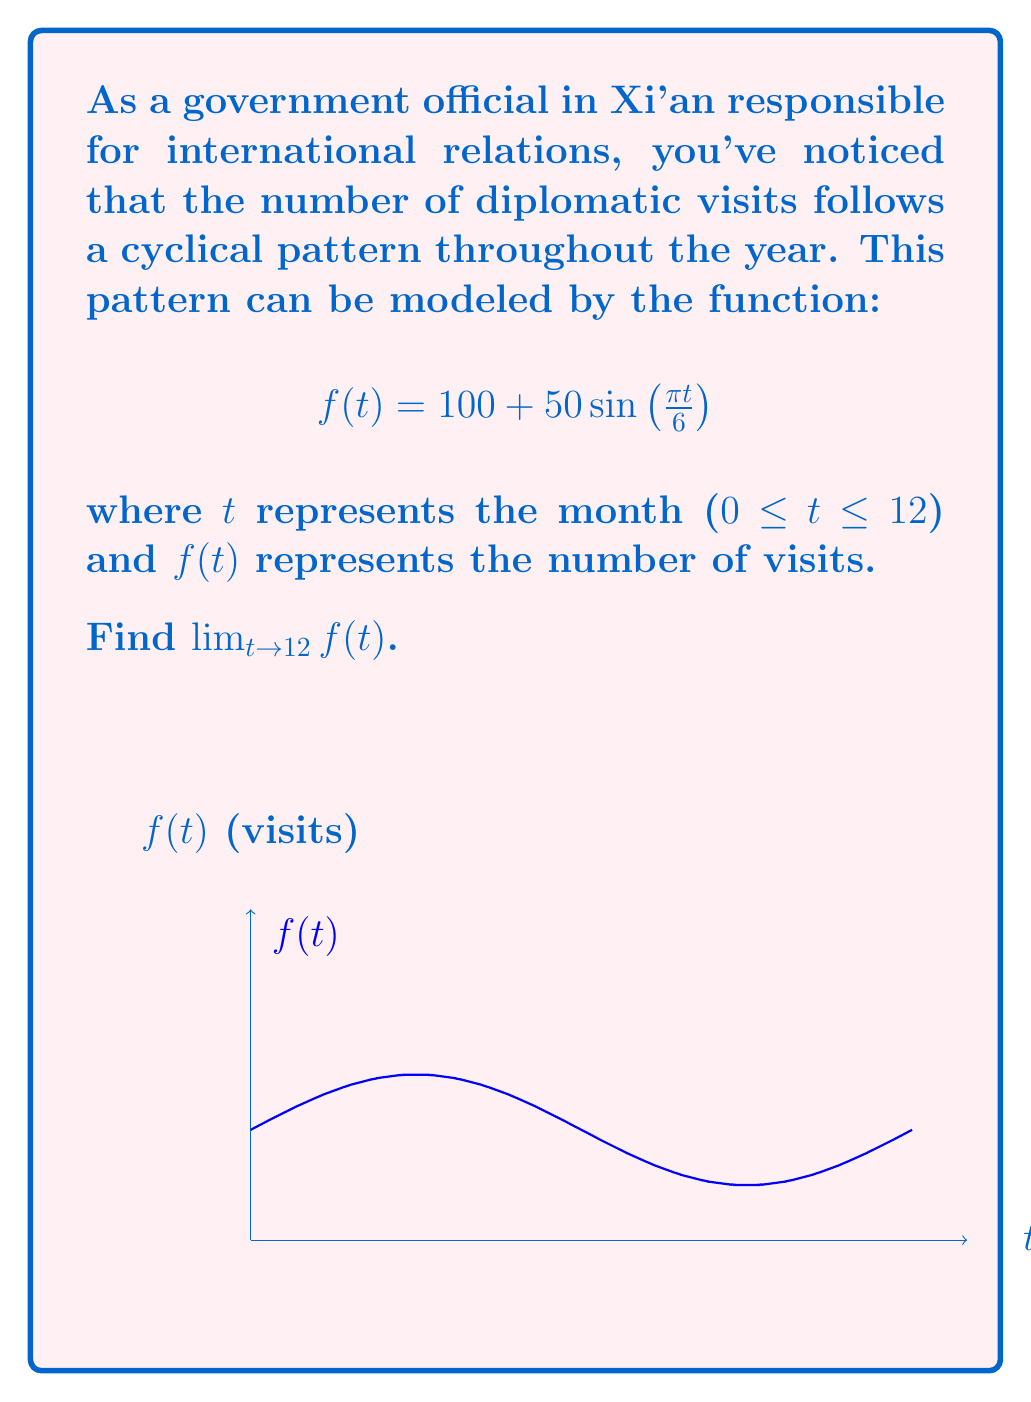Provide a solution to this math problem. Let's approach this step-by-step:

1) We need to evaluate $\lim_{t \to 12} \left(100 + 50\sin\left(\frac{\pi t}{6}\right)\right)$

2) The limit of a sum is the sum of the limits, so we can separate this:
   $\lim_{t \to 12} 100 + \lim_{t \to 12} 50\sin\left(\frac{\pi t}{6}\right)$

3) The first term is a constant, so:
   $100 + \lim_{t \to 12} 50\sin\left(\frac{\pi t}{6}\right)$

4) For the second term, we can factor out the constant:
   $100 + 50 \cdot \lim_{t \to 12} \sin\left(\frac{\pi t}{6}\right)$

5) Now, let's focus on the limit of the sine function:
   $\lim_{t \to 12} \sin\left(\frac{\pi t}{6}\right)$

6) Evaluate the argument as t approaches 12:
   $\frac{\pi \cdot 12}{6} = 2\pi$

7) We know that $\sin(2\pi) = 0$

8) Therefore, $\lim_{t \to 12} \sin\left(\frac{\pi t}{6}\right) = 0$

9) Substituting this back into our original limit:
   $100 + 50 \cdot 0 = 100$

Thus, the limit of the function as t approaches 12 is 100.
Answer: $100$ 